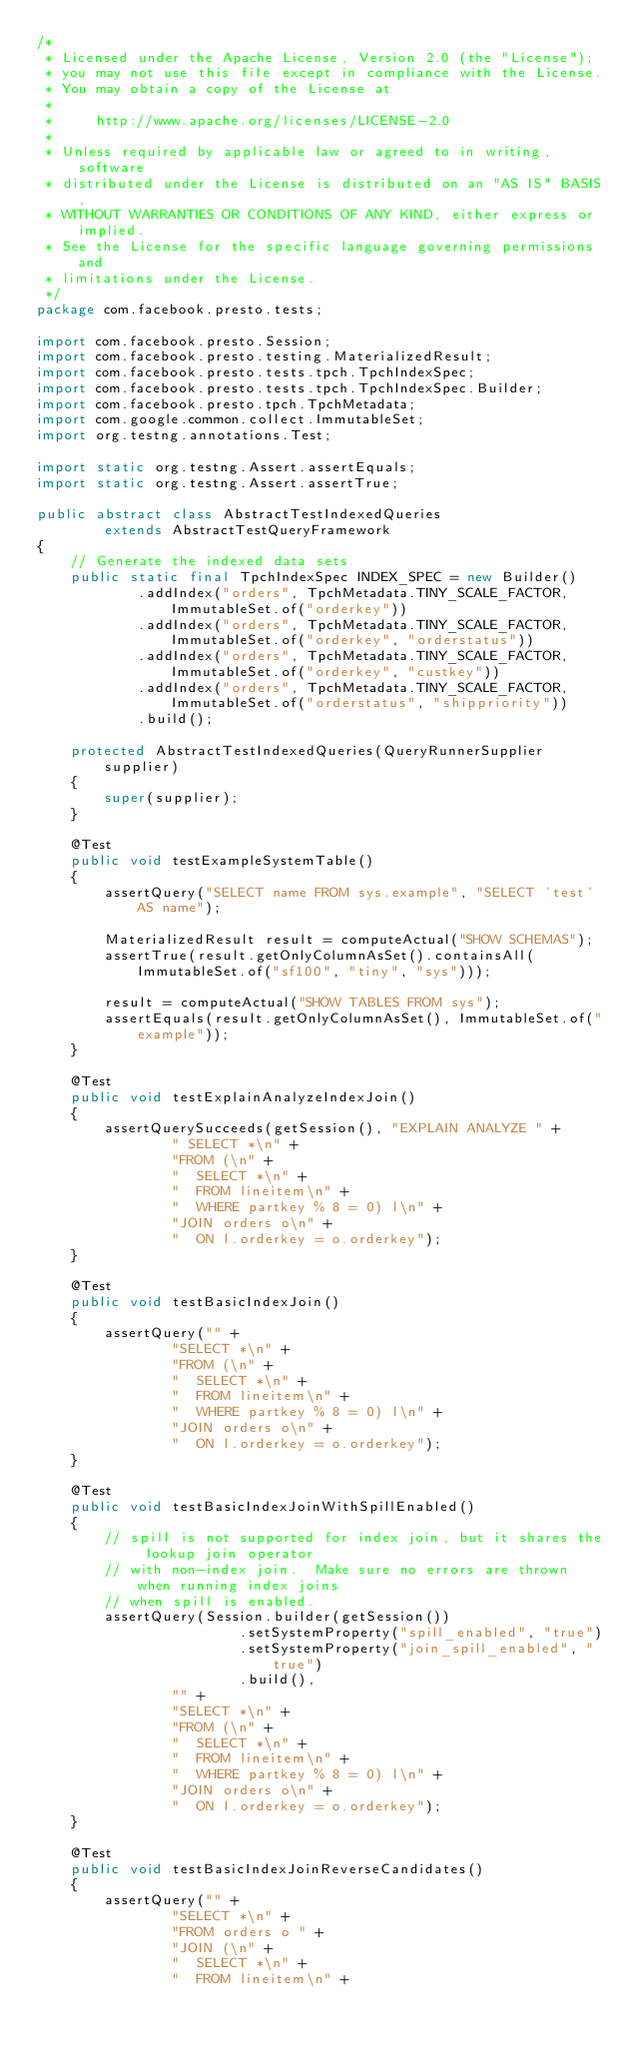Convert code to text. <code><loc_0><loc_0><loc_500><loc_500><_Java_>/*
 * Licensed under the Apache License, Version 2.0 (the "License");
 * you may not use this file except in compliance with the License.
 * You may obtain a copy of the License at
 *
 *     http://www.apache.org/licenses/LICENSE-2.0
 *
 * Unless required by applicable law or agreed to in writing, software
 * distributed under the License is distributed on an "AS IS" BASIS,
 * WITHOUT WARRANTIES OR CONDITIONS OF ANY KIND, either express or implied.
 * See the License for the specific language governing permissions and
 * limitations under the License.
 */
package com.facebook.presto.tests;

import com.facebook.presto.Session;
import com.facebook.presto.testing.MaterializedResult;
import com.facebook.presto.tests.tpch.TpchIndexSpec;
import com.facebook.presto.tests.tpch.TpchIndexSpec.Builder;
import com.facebook.presto.tpch.TpchMetadata;
import com.google.common.collect.ImmutableSet;
import org.testng.annotations.Test;

import static org.testng.Assert.assertEquals;
import static org.testng.Assert.assertTrue;

public abstract class AbstractTestIndexedQueries
        extends AbstractTestQueryFramework
{
    // Generate the indexed data sets
    public static final TpchIndexSpec INDEX_SPEC = new Builder()
            .addIndex("orders", TpchMetadata.TINY_SCALE_FACTOR, ImmutableSet.of("orderkey"))
            .addIndex("orders", TpchMetadata.TINY_SCALE_FACTOR, ImmutableSet.of("orderkey", "orderstatus"))
            .addIndex("orders", TpchMetadata.TINY_SCALE_FACTOR, ImmutableSet.of("orderkey", "custkey"))
            .addIndex("orders", TpchMetadata.TINY_SCALE_FACTOR, ImmutableSet.of("orderstatus", "shippriority"))
            .build();

    protected AbstractTestIndexedQueries(QueryRunnerSupplier supplier)
    {
        super(supplier);
    }

    @Test
    public void testExampleSystemTable()
    {
        assertQuery("SELECT name FROM sys.example", "SELECT 'test' AS name");

        MaterializedResult result = computeActual("SHOW SCHEMAS");
        assertTrue(result.getOnlyColumnAsSet().containsAll(ImmutableSet.of("sf100", "tiny", "sys")));

        result = computeActual("SHOW TABLES FROM sys");
        assertEquals(result.getOnlyColumnAsSet(), ImmutableSet.of("example"));
    }

    @Test
    public void testExplainAnalyzeIndexJoin()
    {
        assertQuerySucceeds(getSession(), "EXPLAIN ANALYZE " +
                " SELECT *\n" +
                "FROM (\n" +
                "  SELECT *\n" +
                "  FROM lineitem\n" +
                "  WHERE partkey % 8 = 0) l\n" +
                "JOIN orders o\n" +
                "  ON l.orderkey = o.orderkey");
    }

    @Test
    public void testBasicIndexJoin()
    {
        assertQuery("" +
                "SELECT *\n" +
                "FROM (\n" +
                "  SELECT *\n" +
                "  FROM lineitem\n" +
                "  WHERE partkey % 8 = 0) l\n" +
                "JOIN orders o\n" +
                "  ON l.orderkey = o.orderkey");
    }

    @Test
    public void testBasicIndexJoinWithSpillEnabled()
    {
        // spill is not supported for index join, but it shares the lookup join operator
        // with non-index join.  Make sure no errors are thrown when running index joins
        // when spill is enabled.
        assertQuery(Session.builder(getSession())
                        .setSystemProperty("spill_enabled", "true")
                        .setSystemProperty("join_spill_enabled", "true")
                        .build(),
                "" +
                "SELECT *\n" +
                "FROM (\n" +
                "  SELECT *\n" +
                "  FROM lineitem\n" +
                "  WHERE partkey % 8 = 0) l\n" +
                "JOIN orders o\n" +
                "  ON l.orderkey = o.orderkey");
    }

    @Test
    public void testBasicIndexJoinReverseCandidates()
    {
        assertQuery("" +
                "SELECT *\n" +
                "FROM orders o " +
                "JOIN (\n" +
                "  SELECT *\n" +
                "  FROM lineitem\n" +</code> 